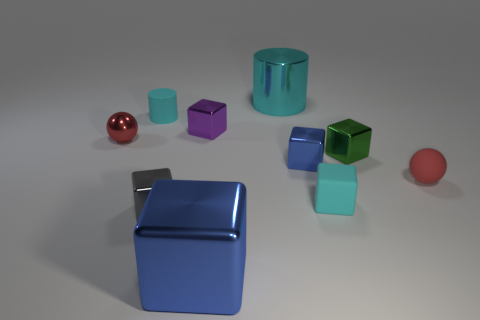Can you describe the surface on which the objects are placed? The objects are placed on a flat, matte gray surface that resembles a tabletop or a floor in a neutral-lit space. Does the surface reflect any of the objects? Yes, it has a slight reflective quality that is noticeable beneath some of the objects, creating faint reflections. 